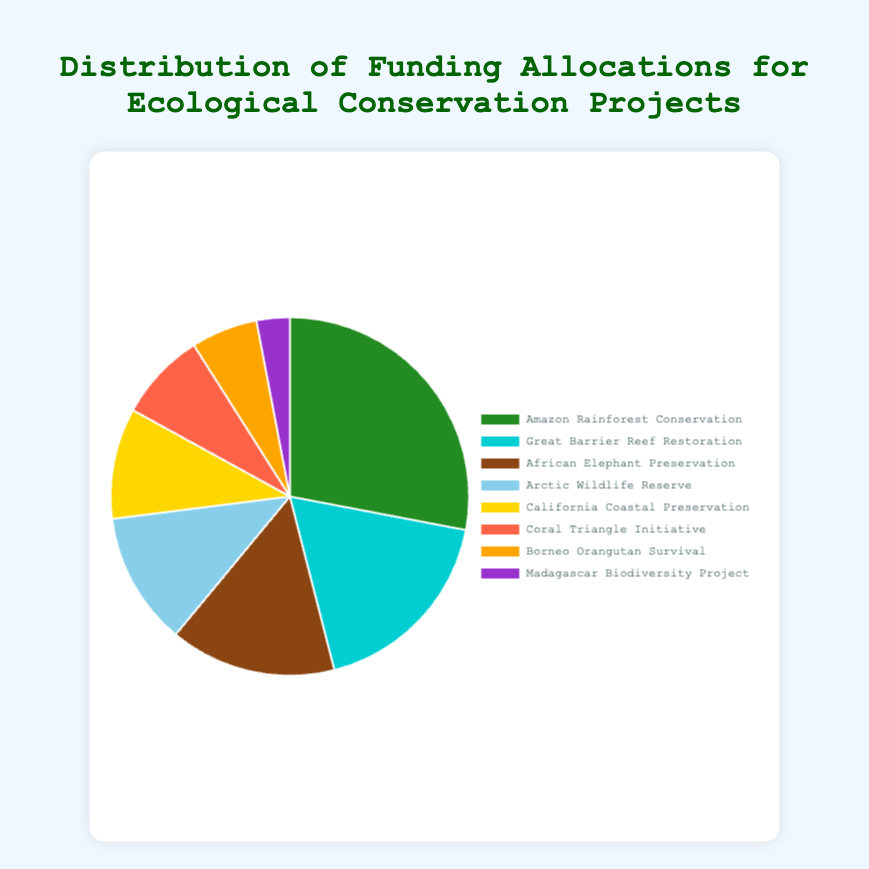Which project received the highest funding allocation? The largest slice of the pie chart represents the project with the highest funding allocation. The Amazon Rainforest Conservation has the largest slice.
Answer: Amazon Rainforest Conservation Which two projects together account for more funding than African Elephant Preservation? African Elephant Preservation has a funding allocation of 15%. To find two projects that together exceed this, we check combinations. Great Barrier Reef Restoration (18%) alone exceeds 15%.
Answer: Great Barrier Reef Restoration What is the total funding allocation for the bottom three projects? Sum the funding allocations for the bottom three projects: Coral Triangle Initiative (8%) + Borneo Orangutan Survival (6%) + Madagascar Biodiversity Project (3%) = 8% + 6% + 3% = 17%.
Answer: 17% Which project is allocated the least amount of funding? The smallest slice on the pie chart represents the Madagascar Biodiversity Project, with a funding allocation of 3%.
Answer: Madagascar Biodiversity Project Which project has a funding allocation that is double that of the Arctic Wildlife Reserve? The Arctic Wildlife Reserve has a funding allocation of 12%. Doubling this allocation, 12% * 2 = 24%. The Amazon Rainforest Conservation (28%) is closest to double the amount.
Answer: Amazon Rainforest Conservation How does the funding allocation for California Coastal Preservation compare to that of Coral Triangle Initiative? California Coastal Preservation has a funding allocation of 10% and Coral Triangle Initiative has 8%. Therefore, California Coastal Preservation has a higher funding allocation.
Answer: California Coastal Preservation What is the difference in funding allocation between Borneo Orangutan Survival and Arctic Wildlife Reserve? The Arctic Wildlife Reserve has a 12% allocation, and the Borneo Orangutan Survival has a 6% allocation. The difference is 12% - 6% = 6%.
Answer: 6% Which project receives slightly more funding than Coral Triangle Initiative? The Coral Triangle Initiative receives 8% of the funding. The next project up is California Coastal Preservation with a 10% allocation.
Answer: California Coastal Preservation Identify the project with a yellow-colored slice. Yellow is used to denote California Coastal Preservation on the pie chart.
Answer: California Coastal Preservation 